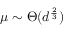Convert formula to latex. <formula><loc_0><loc_0><loc_500><loc_500>\mu \sim \Theta ( d ^ { \frac { 2 } { 3 } } )</formula> 